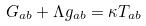<formula> <loc_0><loc_0><loc_500><loc_500>G _ { a b } + \Lambda g _ { a b } = \kappa T _ { a b }</formula> 